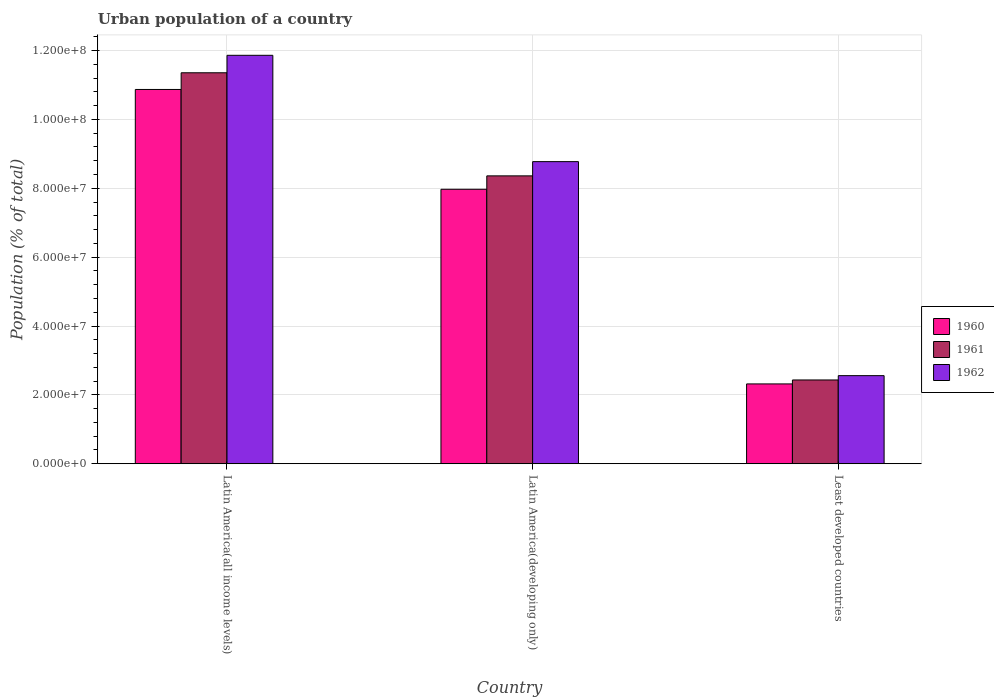How many different coloured bars are there?
Offer a very short reply. 3. Are the number of bars on each tick of the X-axis equal?
Your answer should be compact. Yes. How many bars are there on the 1st tick from the left?
Keep it short and to the point. 3. What is the label of the 2nd group of bars from the left?
Make the answer very short. Latin America(developing only). What is the urban population in 1962 in Least developed countries?
Give a very brief answer. 2.56e+07. Across all countries, what is the maximum urban population in 1960?
Provide a short and direct response. 1.09e+08. Across all countries, what is the minimum urban population in 1960?
Make the answer very short. 2.32e+07. In which country was the urban population in 1961 maximum?
Offer a terse response. Latin America(all income levels). In which country was the urban population in 1960 minimum?
Offer a very short reply. Least developed countries. What is the total urban population in 1960 in the graph?
Provide a short and direct response. 2.12e+08. What is the difference between the urban population in 1962 in Latin America(all income levels) and that in Least developed countries?
Make the answer very short. 9.30e+07. What is the difference between the urban population in 1962 in Latin America(developing only) and the urban population in 1961 in Least developed countries?
Your answer should be compact. 6.34e+07. What is the average urban population in 1962 per country?
Ensure brevity in your answer.  7.73e+07. What is the difference between the urban population of/in 1962 and urban population of/in 1960 in Latin America(all income levels)?
Ensure brevity in your answer.  9.92e+06. What is the ratio of the urban population in 1960 in Latin America(all income levels) to that in Least developed countries?
Provide a succinct answer. 4.69. Is the difference between the urban population in 1962 in Latin America(developing only) and Least developed countries greater than the difference between the urban population in 1960 in Latin America(developing only) and Least developed countries?
Your answer should be very brief. Yes. What is the difference between the highest and the second highest urban population in 1961?
Your response must be concise. 5.93e+07. What is the difference between the highest and the lowest urban population in 1960?
Keep it short and to the point. 8.55e+07. In how many countries, is the urban population in 1962 greater than the average urban population in 1962 taken over all countries?
Provide a short and direct response. 2. Is the sum of the urban population in 1960 in Latin America(developing only) and Least developed countries greater than the maximum urban population in 1961 across all countries?
Provide a short and direct response. No. Are all the bars in the graph horizontal?
Offer a terse response. No. How many countries are there in the graph?
Make the answer very short. 3. What is the difference between two consecutive major ticks on the Y-axis?
Keep it short and to the point. 2.00e+07. Does the graph contain any zero values?
Ensure brevity in your answer.  No. Does the graph contain grids?
Your answer should be compact. Yes. How many legend labels are there?
Provide a short and direct response. 3. How are the legend labels stacked?
Ensure brevity in your answer.  Vertical. What is the title of the graph?
Your answer should be compact. Urban population of a country. Does "2007" appear as one of the legend labels in the graph?
Ensure brevity in your answer.  No. What is the label or title of the X-axis?
Make the answer very short. Country. What is the label or title of the Y-axis?
Your response must be concise. Population (% of total). What is the Population (% of total) of 1960 in Latin America(all income levels)?
Your answer should be compact. 1.09e+08. What is the Population (% of total) of 1961 in Latin America(all income levels)?
Provide a succinct answer. 1.14e+08. What is the Population (% of total) in 1962 in Latin America(all income levels)?
Offer a very short reply. 1.19e+08. What is the Population (% of total) in 1960 in Latin America(developing only)?
Your response must be concise. 7.97e+07. What is the Population (% of total) in 1961 in Latin America(developing only)?
Provide a short and direct response. 8.36e+07. What is the Population (% of total) in 1962 in Latin America(developing only)?
Ensure brevity in your answer.  8.77e+07. What is the Population (% of total) in 1960 in Least developed countries?
Your answer should be very brief. 2.32e+07. What is the Population (% of total) in 1961 in Least developed countries?
Give a very brief answer. 2.43e+07. What is the Population (% of total) of 1962 in Least developed countries?
Your answer should be very brief. 2.56e+07. Across all countries, what is the maximum Population (% of total) in 1960?
Provide a short and direct response. 1.09e+08. Across all countries, what is the maximum Population (% of total) in 1961?
Your answer should be very brief. 1.14e+08. Across all countries, what is the maximum Population (% of total) of 1962?
Keep it short and to the point. 1.19e+08. Across all countries, what is the minimum Population (% of total) in 1960?
Ensure brevity in your answer.  2.32e+07. Across all countries, what is the minimum Population (% of total) of 1961?
Your response must be concise. 2.43e+07. Across all countries, what is the minimum Population (% of total) in 1962?
Your answer should be compact. 2.56e+07. What is the total Population (% of total) in 1960 in the graph?
Your response must be concise. 2.12e+08. What is the total Population (% of total) of 1961 in the graph?
Your answer should be compact. 2.21e+08. What is the total Population (% of total) in 1962 in the graph?
Provide a short and direct response. 2.32e+08. What is the difference between the Population (% of total) in 1960 in Latin America(all income levels) and that in Latin America(developing only)?
Make the answer very short. 2.90e+07. What is the difference between the Population (% of total) in 1961 in Latin America(all income levels) and that in Latin America(developing only)?
Offer a terse response. 2.99e+07. What is the difference between the Population (% of total) in 1962 in Latin America(all income levels) and that in Latin America(developing only)?
Your response must be concise. 3.09e+07. What is the difference between the Population (% of total) of 1960 in Latin America(all income levels) and that in Least developed countries?
Offer a very short reply. 8.55e+07. What is the difference between the Population (% of total) of 1961 in Latin America(all income levels) and that in Least developed countries?
Provide a short and direct response. 8.92e+07. What is the difference between the Population (% of total) in 1962 in Latin America(all income levels) and that in Least developed countries?
Keep it short and to the point. 9.30e+07. What is the difference between the Population (% of total) of 1960 in Latin America(developing only) and that in Least developed countries?
Keep it short and to the point. 5.65e+07. What is the difference between the Population (% of total) in 1961 in Latin America(developing only) and that in Least developed countries?
Your answer should be very brief. 5.93e+07. What is the difference between the Population (% of total) in 1962 in Latin America(developing only) and that in Least developed countries?
Keep it short and to the point. 6.22e+07. What is the difference between the Population (% of total) of 1960 in Latin America(all income levels) and the Population (% of total) of 1961 in Latin America(developing only)?
Make the answer very short. 2.51e+07. What is the difference between the Population (% of total) of 1960 in Latin America(all income levels) and the Population (% of total) of 1962 in Latin America(developing only)?
Make the answer very short. 2.10e+07. What is the difference between the Population (% of total) in 1961 in Latin America(all income levels) and the Population (% of total) in 1962 in Latin America(developing only)?
Provide a succinct answer. 2.58e+07. What is the difference between the Population (% of total) in 1960 in Latin America(all income levels) and the Population (% of total) in 1961 in Least developed countries?
Make the answer very short. 8.44e+07. What is the difference between the Population (% of total) in 1960 in Latin America(all income levels) and the Population (% of total) in 1962 in Least developed countries?
Your response must be concise. 8.31e+07. What is the difference between the Population (% of total) in 1961 in Latin America(all income levels) and the Population (% of total) in 1962 in Least developed countries?
Provide a succinct answer. 8.80e+07. What is the difference between the Population (% of total) in 1960 in Latin America(developing only) and the Population (% of total) in 1961 in Least developed countries?
Offer a terse response. 5.54e+07. What is the difference between the Population (% of total) of 1960 in Latin America(developing only) and the Population (% of total) of 1962 in Least developed countries?
Provide a succinct answer. 5.41e+07. What is the difference between the Population (% of total) of 1961 in Latin America(developing only) and the Population (% of total) of 1962 in Least developed countries?
Make the answer very short. 5.80e+07. What is the average Population (% of total) of 1960 per country?
Your answer should be very brief. 7.05e+07. What is the average Population (% of total) in 1961 per country?
Ensure brevity in your answer.  7.38e+07. What is the average Population (% of total) in 1962 per country?
Provide a succinct answer. 7.73e+07. What is the difference between the Population (% of total) of 1960 and Population (% of total) of 1961 in Latin America(all income levels)?
Give a very brief answer. -4.84e+06. What is the difference between the Population (% of total) in 1960 and Population (% of total) in 1962 in Latin America(all income levels)?
Provide a short and direct response. -9.92e+06. What is the difference between the Population (% of total) of 1961 and Population (% of total) of 1962 in Latin America(all income levels)?
Offer a very short reply. -5.08e+06. What is the difference between the Population (% of total) of 1960 and Population (% of total) of 1961 in Latin America(developing only)?
Offer a very short reply. -3.89e+06. What is the difference between the Population (% of total) in 1960 and Population (% of total) in 1962 in Latin America(developing only)?
Make the answer very short. -8.03e+06. What is the difference between the Population (% of total) of 1961 and Population (% of total) of 1962 in Latin America(developing only)?
Make the answer very short. -4.13e+06. What is the difference between the Population (% of total) in 1960 and Population (% of total) in 1961 in Least developed countries?
Ensure brevity in your answer.  -1.15e+06. What is the difference between the Population (% of total) of 1960 and Population (% of total) of 1962 in Least developed countries?
Your answer should be compact. -2.40e+06. What is the difference between the Population (% of total) of 1961 and Population (% of total) of 1962 in Least developed countries?
Your answer should be compact. -1.25e+06. What is the ratio of the Population (% of total) in 1960 in Latin America(all income levels) to that in Latin America(developing only)?
Give a very brief answer. 1.36. What is the ratio of the Population (% of total) in 1961 in Latin America(all income levels) to that in Latin America(developing only)?
Your answer should be very brief. 1.36. What is the ratio of the Population (% of total) of 1962 in Latin America(all income levels) to that in Latin America(developing only)?
Offer a very short reply. 1.35. What is the ratio of the Population (% of total) in 1960 in Latin America(all income levels) to that in Least developed countries?
Ensure brevity in your answer.  4.69. What is the ratio of the Population (% of total) in 1961 in Latin America(all income levels) to that in Least developed countries?
Your response must be concise. 4.67. What is the ratio of the Population (% of total) in 1962 in Latin America(all income levels) to that in Least developed countries?
Provide a succinct answer. 4.64. What is the ratio of the Population (% of total) of 1960 in Latin America(developing only) to that in Least developed countries?
Provide a succinct answer. 3.44. What is the ratio of the Population (% of total) of 1961 in Latin America(developing only) to that in Least developed countries?
Offer a terse response. 3.44. What is the ratio of the Population (% of total) in 1962 in Latin America(developing only) to that in Least developed countries?
Your response must be concise. 3.43. What is the difference between the highest and the second highest Population (% of total) in 1960?
Keep it short and to the point. 2.90e+07. What is the difference between the highest and the second highest Population (% of total) of 1961?
Your answer should be very brief. 2.99e+07. What is the difference between the highest and the second highest Population (% of total) of 1962?
Provide a short and direct response. 3.09e+07. What is the difference between the highest and the lowest Population (% of total) of 1960?
Keep it short and to the point. 8.55e+07. What is the difference between the highest and the lowest Population (% of total) of 1961?
Your answer should be very brief. 8.92e+07. What is the difference between the highest and the lowest Population (% of total) of 1962?
Keep it short and to the point. 9.30e+07. 